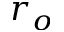Convert formula to latex. <formula><loc_0><loc_0><loc_500><loc_500>r _ { o }</formula> 